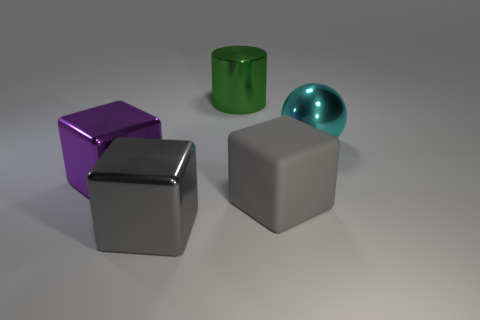Do the metal cube in front of the matte cube and the rubber object have the same color?
Provide a succinct answer. Yes. Does the thing in front of the big gray rubber block have the same color as the large cube to the right of the big shiny cylinder?
Your answer should be compact. Yes. Is the big gray thing right of the large green shiny cylinder made of the same material as the large cyan thing?
Provide a short and direct response. No. What is the shape of the big shiny object that is in front of the big cyan metal ball and behind the matte block?
Give a very brief answer. Cube. Does the cyan metallic sphere have the same size as the gray metal block?
Ensure brevity in your answer.  Yes. What number of gray metallic blocks are in front of the big green metal object?
Provide a succinct answer. 1. Are there an equal number of big gray things to the left of the big shiny ball and cyan shiny balls that are behind the green metal object?
Offer a very short reply. No. Is the shape of the large metal object in front of the purple thing the same as  the rubber object?
Offer a terse response. Yes. What number of other objects are there of the same color as the large cylinder?
Keep it short and to the point. 0. Are there any metal things in front of the cyan metal thing?
Your response must be concise. Yes. 